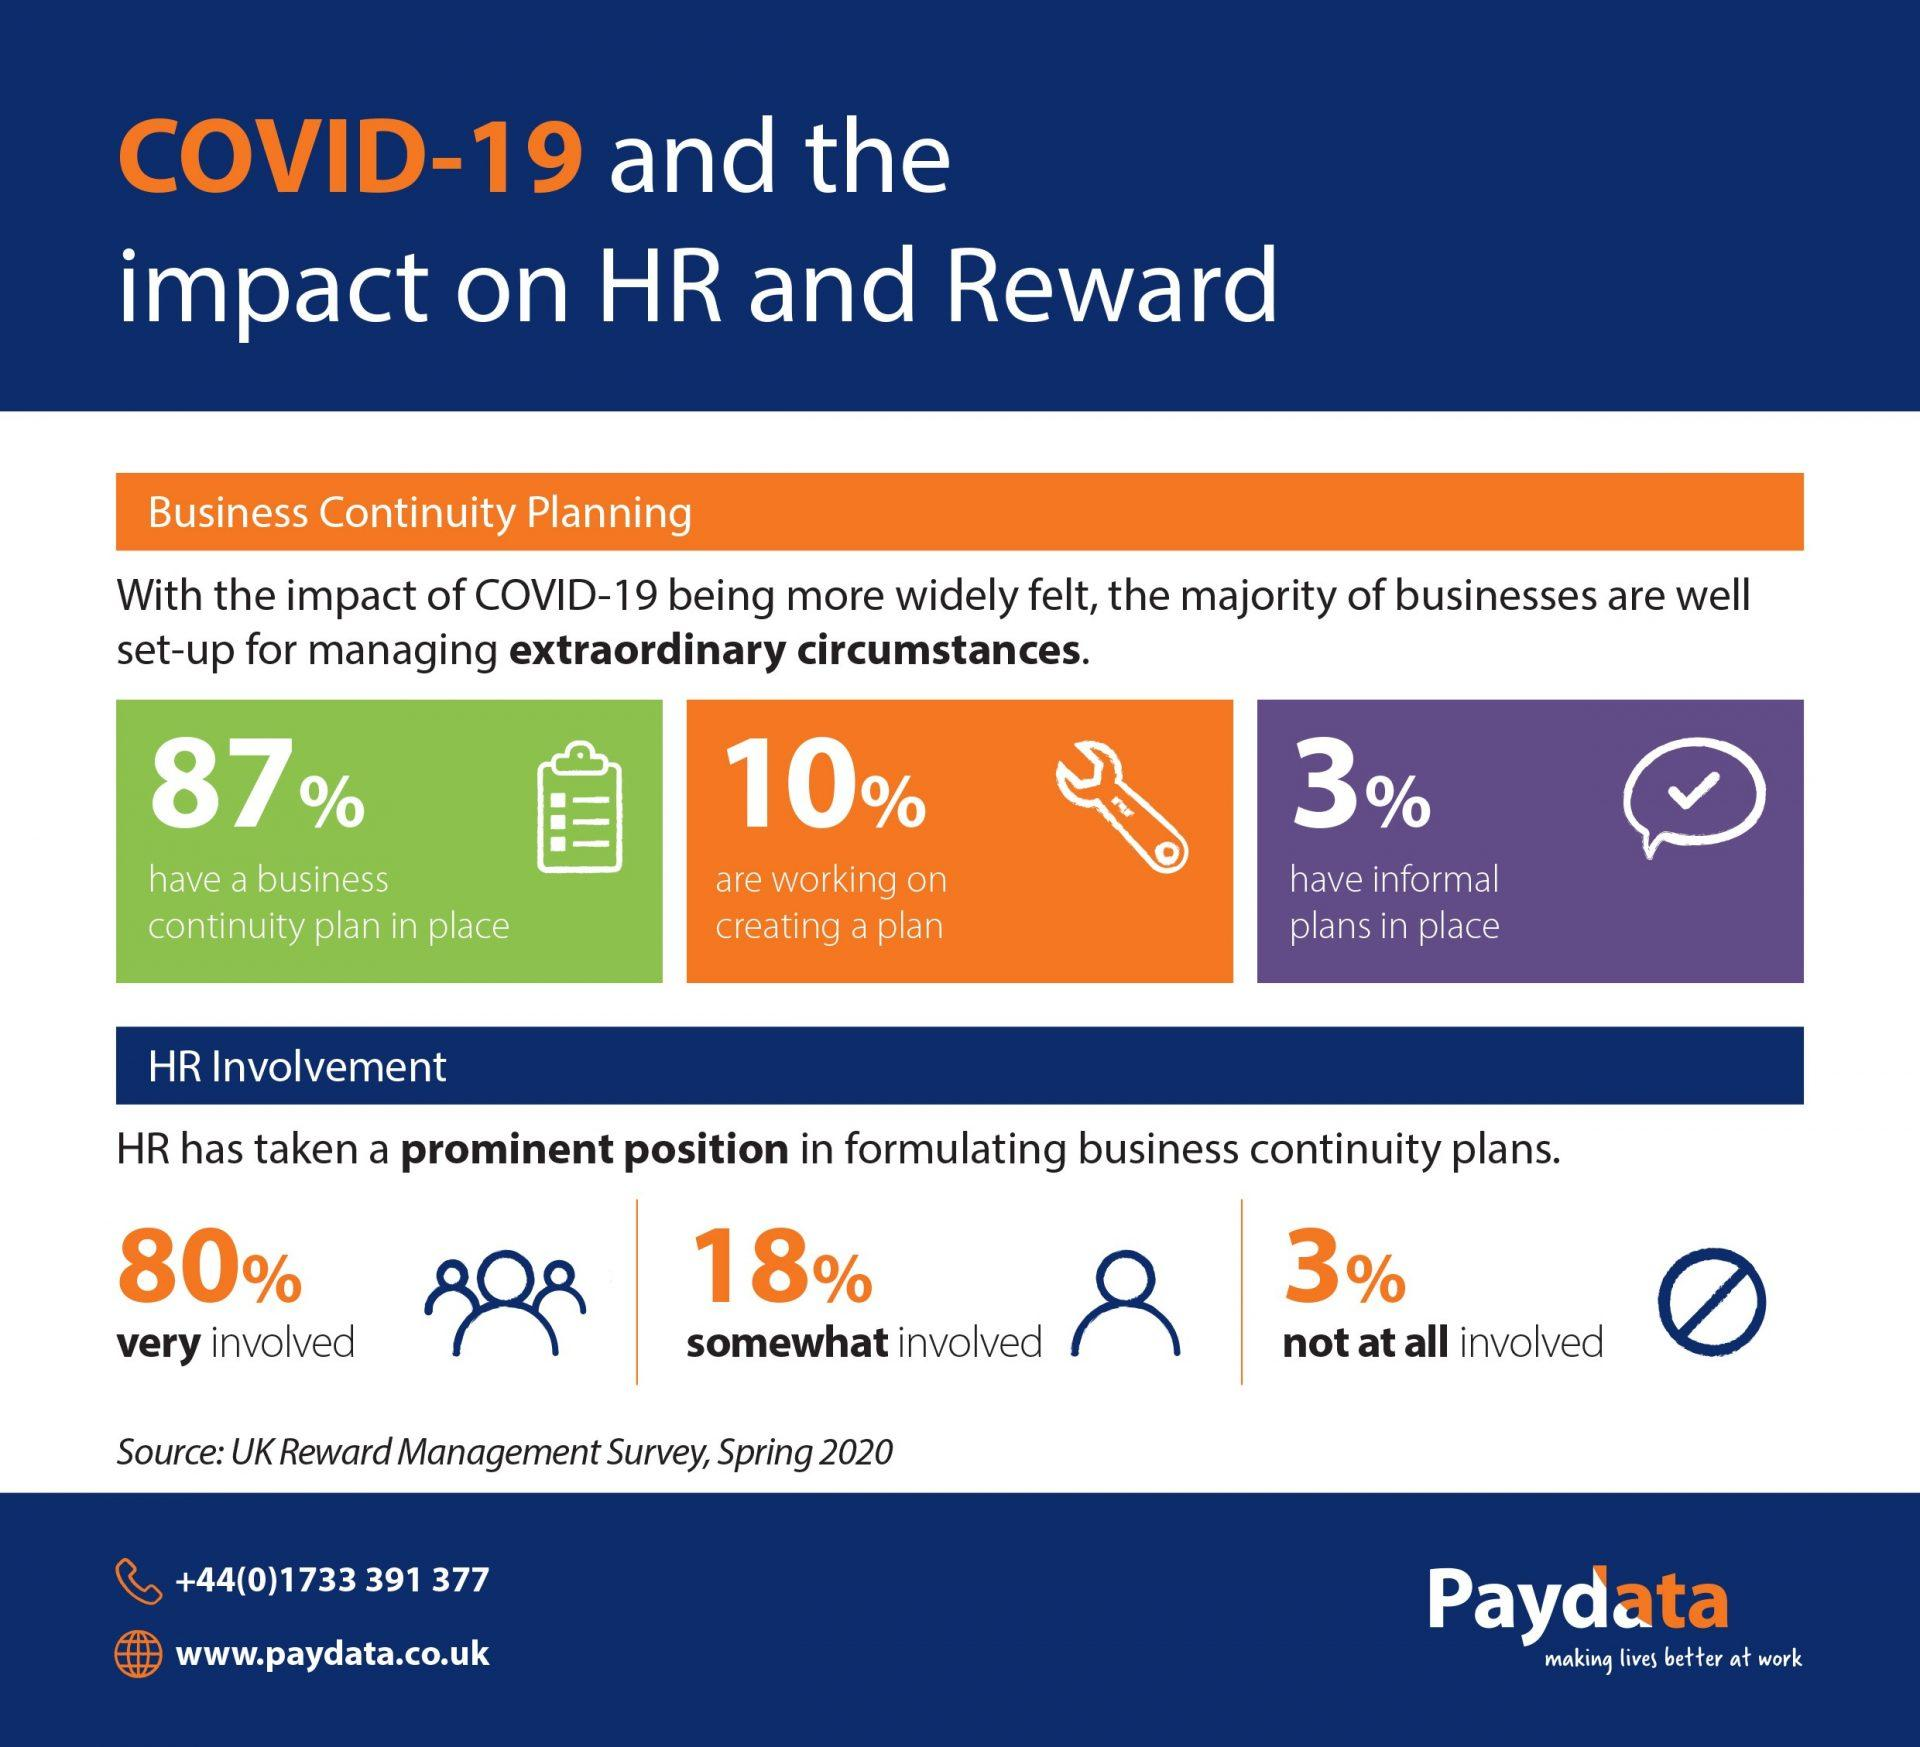Outline some significant characteristics in this image. It is estimated that only 10% of businesses are actively working on creating a plan. According to the given statistic, only 3% of HR professionals are not at all involved in formulating business continuity plans. Eighty percent of HR professionals are highly involved in creating business continuity plans, indicating a strong commitment to ensuring the continued operation of their organization during times of crisis. Approximately 13% of businesses do not have a continuity plan in place to prepare for potential disruptions. According to a recent study, only 3% of businesses have informal plans in place. 